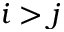<formula> <loc_0><loc_0><loc_500><loc_500>i > j</formula> 